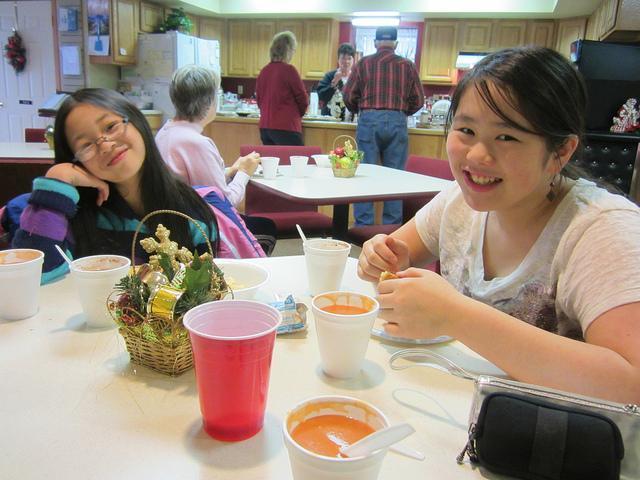How many people are there?
Give a very brief answer. 6. How many people are visible?
Give a very brief answer. 5. How many dining tables are there?
Give a very brief answer. 2. How many chairs are visible?
Give a very brief answer. 2. How many cups are there?
Give a very brief answer. 6. 